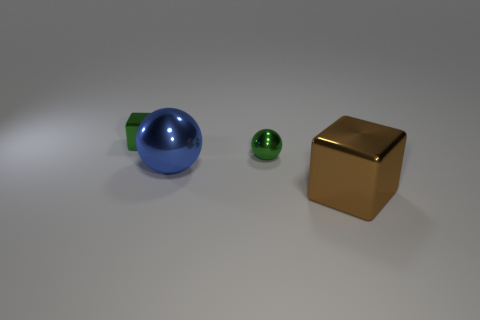The block to the right of the metallic block behind the small green metallic object that is to the right of the big blue shiny sphere is what color?
Your answer should be compact. Brown. There is a tiny thing that is in front of the tiny shiny block; does it have the same color as the big ball?
Provide a short and direct response. No. What number of other things are there of the same color as the small metal cube?
Ensure brevity in your answer.  1. How many things are spheres or small yellow matte objects?
Give a very brief answer. 2. How many objects are either large purple balls or large blue metallic balls that are in front of the small green block?
Make the answer very short. 1. Are the small ball and the big blue ball made of the same material?
Your response must be concise. Yes. How many other things are there of the same material as the small sphere?
Give a very brief answer. 3. Are there more small gray metallic objects than tiny metallic things?
Provide a succinct answer. No. There is a small green thing that is to the left of the tiny sphere; is it the same shape as the blue metallic thing?
Your answer should be compact. No. Are there fewer tiny green metallic spheres than small objects?
Ensure brevity in your answer.  Yes. 